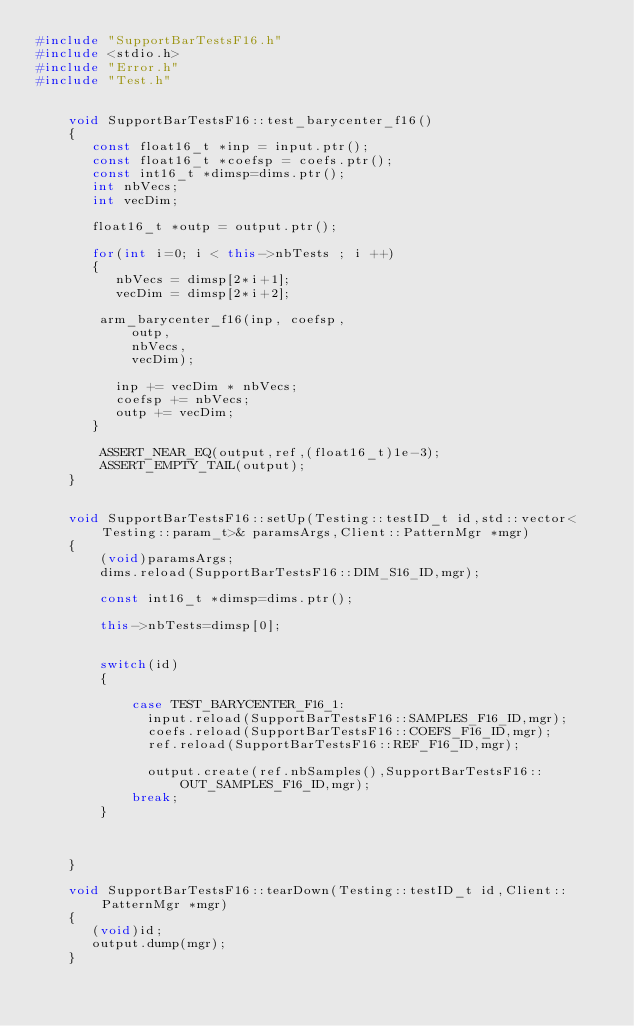Convert code to text. <code><loc_0><loc_0><loc_500><loc_500><_C++_>#include "SupportBarTestsF16.h"
#include <stdio.h>
#include "Error.h"
#include "Test.h"


    void SupportBarTestsF16::test_barycenter_f16()
    {
       const float16_t *inp = input.ptr();
       const float16_t *coefsp = coefs.ptr();
       const int16_t *dimsp=dims.ptr();
       int nbVecs;
       int vecDim;

       float16_t *outp = output.ptr();
       
       for(int i=0; i < this->nbTests ; i ++)
       {
          nbVecs = dimsp[2*i+1];
          vecDim = dimsp[2*i+2];

        arm_barycenter_f16(inp, coefsp,
            outp, 
            nbVecs, 
            vecDim);
         
          inp += vecDim * nbVecs;
          coefsp += nbVecs;
          outp += vecDim;
       }

        ASSERT_NEAR_EQ(output,ref,(float16_t)1e-3);
        ASSERT_EMPTY_TAIL(output);
    } 

  
    void SupportBarTestsF16::setUp(Testing::testID_t id,std::vector<Testing::param_t>& paramsArgs,Client::PatternMgr *mgr)
    {
        (void)paramsArgs;
        dims.reload(SupportBarTestsF16::DIM_S16_ID,mgr);

        const int16_t *dimsp=dims.ptr();

        this->nbTests=dimsp[0];
       

        switch(id)
        {
           
            case TEST_BARYCENTER_F16_1:
              input.reload(SupportBarTestsF16::SAMPLES_F16_ID,mgr);
              coefs.reload(SupportBarTestsF16::COEFS_F16_ID,mgr);
              ref.reload(SupportBarTestsF16::REF_F16_ID,mgr);

              output.create(ref.nbSamples(),SupportBarTestsF16::OUT_SAMPLES_F16_ID,mgr);
            break;
        }

       

    }

    void SupportBarTestsF16::tearDown(Testing::testID_t id,Client::PatternMgr *mgr)
    {
       (void)id;
       output.dump(mgr);
    }
</code> 